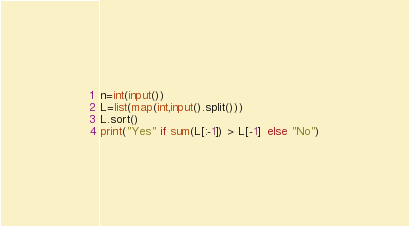<code> <loc_0><loc_0><loc_500><loc_500><_Python_>n=int(input())
L=list(map(int,input().split()))
L.sort()
print("Yes" if sum(L[:-1]) > L[-1]  else "No")
</code> 